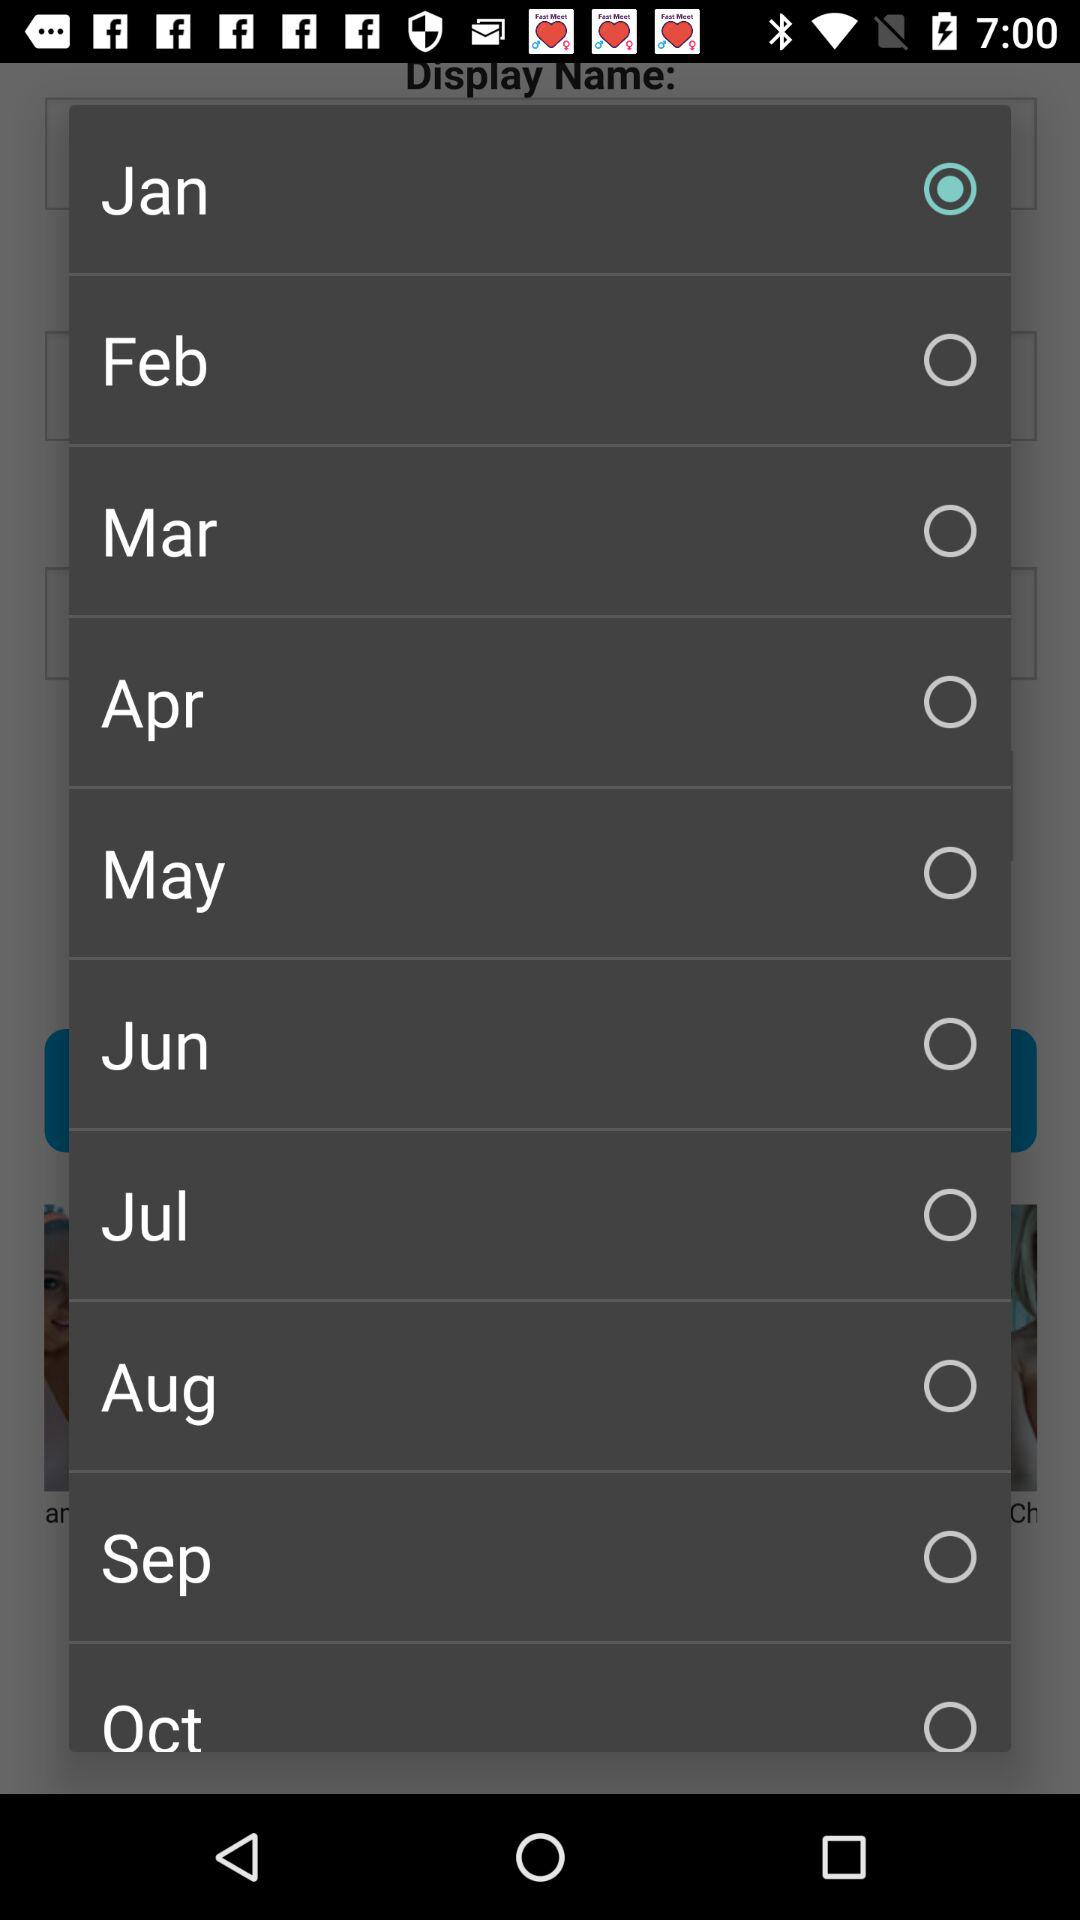Which year is selected?
When the provided information is insufficient, respond with <no answer>. <no answer> 